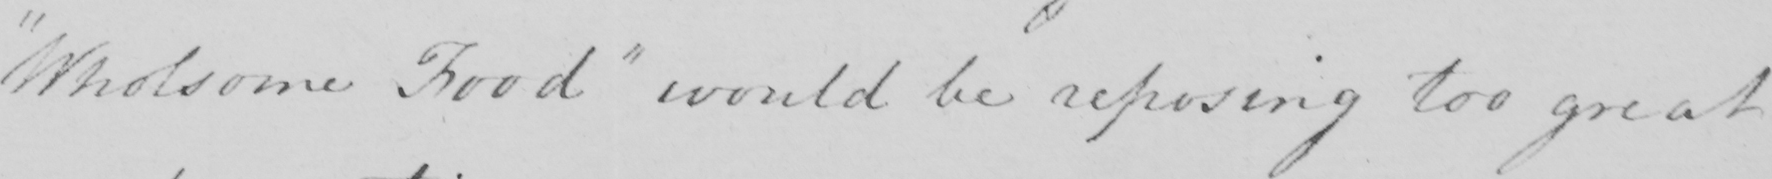What does this handwritten line say? " Wholsome Food "  would be reposing too great 